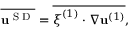<formula> <loc_0><loc_0><loc_500><loc_500>\overline { { u ^ { S D } } } = \overline { { \xi ^ { ( 1 ) } \cdot \nabla u ^ { ( 1 ) } } } ,</formula> 